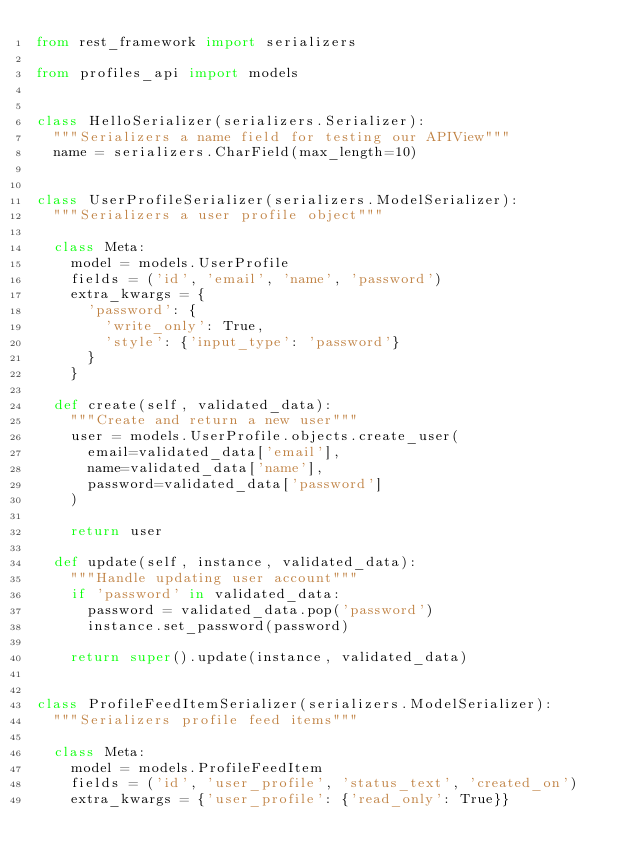<code> <loc_0><loc_0><loc_500><loc_500><_Python_>from rest_framework import serializers

from profiles_api import models


class HelloSerializer(serializers.Serializer):
  """Serializers a name field for testing our APIView"""
  name = serializers.CharField(max_length=10)


class UserProfileSerializer(serializers.ModelSerializer):
  """Serializers a user profile object"""

  class Meta:
    model = models.UserProfile
    fields = ('id', 'email', 'name', 'password')
    extra_kwargs = {
      'password': {
        'write_only': True,
        'style': {'input_type': 'password'}
      }
    }

  def create(self, validated_data):
    """Create and return a new user"""
    user = models.UserProfile.objects.create_user(
      email=validated_data['email'],
      name=validated_data['name'],
      password=validated_data['password']
    )

    return user

  def update(self, instance, validated_data):
    """Handle updating user account"""
    if 'password' in validated_data:
      password = validated_data.pop('password')
      instance.set_password(password)

    return super().update(instance, validated_data)


class ProfileFeedItemSerializer(serializers.ModelSerializer):
  """Serializers profile feed items"""

  class Meta:
    model = models.ProfileFeedItem
    fields = ('id', 'user_profile', 'status_text', 'created_on')
    extra_kwargs = {'user_profile': {'read_only': True}}
</code> 